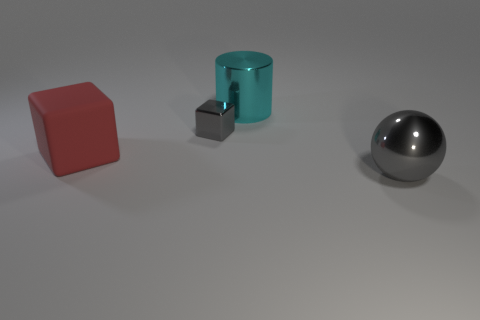Is the size of the red block the same as the metallic object that is behind the tiny metallic object?
Provide a short and direct response. Yes. How many matte objects are tiny gray blocks or large cyan cylinders?
Provide a succinct answer. 0. Are there any other things that are the same material as the large block?
Offer a terse response. No. Is the color of the metallic block the same as the metallic object right of the cyan object?
Make the answer very short. Yes. The large cyan shiny object has what shape?
Ensure brevity in your answer.  Cylinder. What size is the gray thing that is to the left of the thing to the right of the large metal object behind the big matte object?
Your answer should be very brief. Small. How many other objects are the same shape as the large cyan shiny thing?
Give a very brief answer. 0. Do the small object that is to the right of the large red thing and the big object that is on the left side of the large cyan cylinder have the same shape?
Your answer should be very brief. Yes. What number of spheres are shiny objects or tiny blue shiny things?
Keep it short and to the point. 1. What is the cube in front of the shiny thing that is left of the big shiny thing behind the big gray metallic object made of?
Offer a terse response. Rubber. 